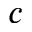Convert formula to latex. <formula><loc_0><loc_0><loc_500><loc_500>c</formula> 